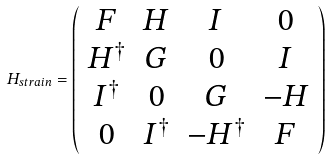Convert formula to latex. <formula><loc_0><loc_0><loc_500><loc_500>H _ { s t r a i n } = \left ( \begin{array} { c c c c } F & H & I & 0 \\ H ^ { \dagger } & G & 0 & I \\ I ^ { \dagger } & 0 & G & - H \\ 0 & I ^ { \dagger } & - H ^ { \dagger } & F \end{array} \right ) \</formula> 